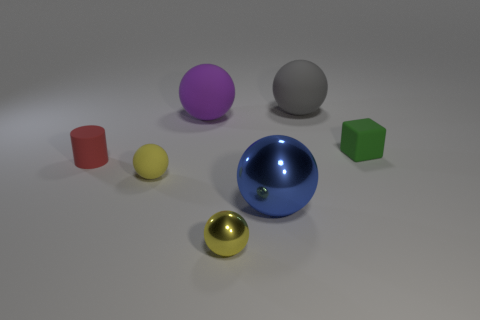The small object that is in front of the small cylinder and to the right of the tiny yellow rubber sphere has what shape?
Your answer should be compact. Sphere. Is there a purple rubber object of the same shape as the big blue metallic thing?
Provide a succinct answer. Yes. There is a yellow matte object that is the same size as the red matte cylinder; what shape is it?
Your answer should be very brief. Sphere. What is the material of the purple ball?
Your answer should be compact. Rubber. How big is the rubber ball that is in front of the tiny rubber thing right of the big sphere in front of the yellow matte sphere?
Give a very brief answer. Small. What is the material of the thing that is the same color as the small metallic ball?
Give a very brief answer. Rubber. What number of rubber objects are big spheres or red cylinders?
Your answer should be very brief. 3. What is the size of the purple matte ball?
Provide a short and direct response. Large. What number of things are either tiny rubber cylinders or matte things that are left of the gray thing?
Give a very brief answer. 3. How many other things are the same color as the tiny matte ball?
Offer a terse response. 1. 